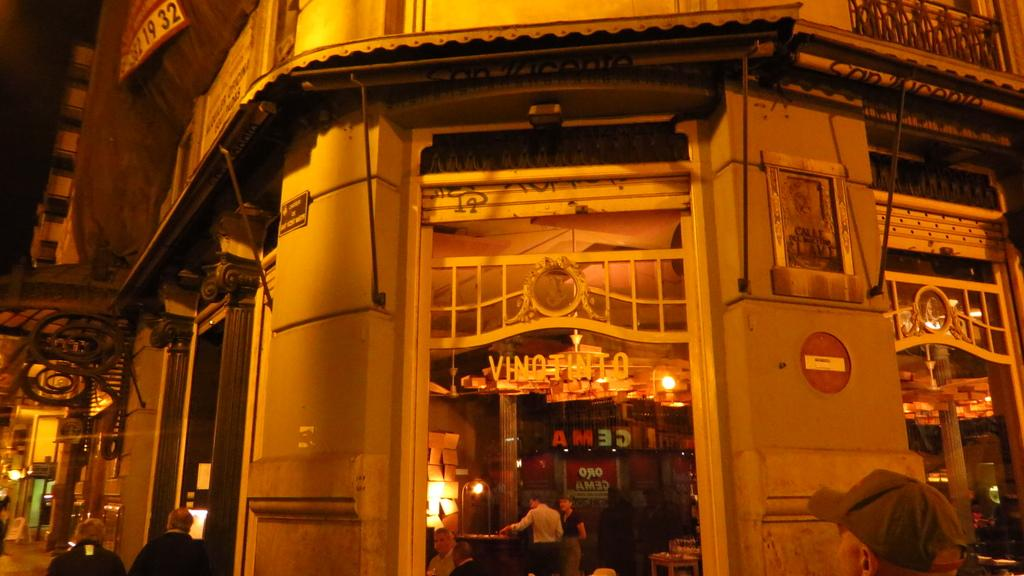What type of structures can be seen in the image? There are buildings in the image. What is happening on the road in the image? There are people on the road in the image. What is the taste of the buildings in the image? Buildings do not have a taste; they are inanimate structures. 